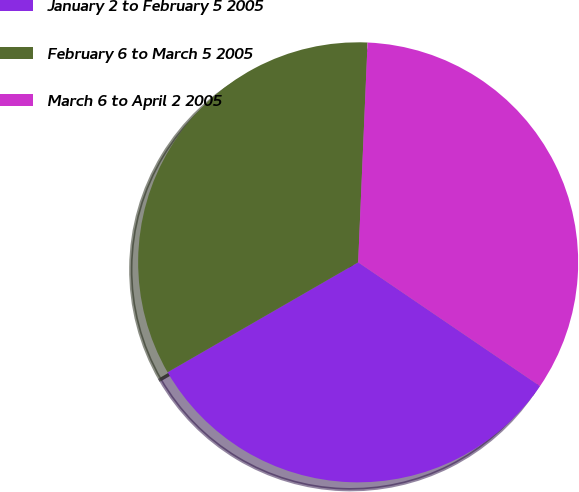<chart> <loc_0><loc_0><loc_500><loc_500><pie_chart><fcel>January 2 to February 5 2005<fcel>February 6 to March 5 2005<fcel>March 6 to April 2 2005<nl><fcel>32.16%<fcel>34.01%<fcel>33.83%<nl></chart> 